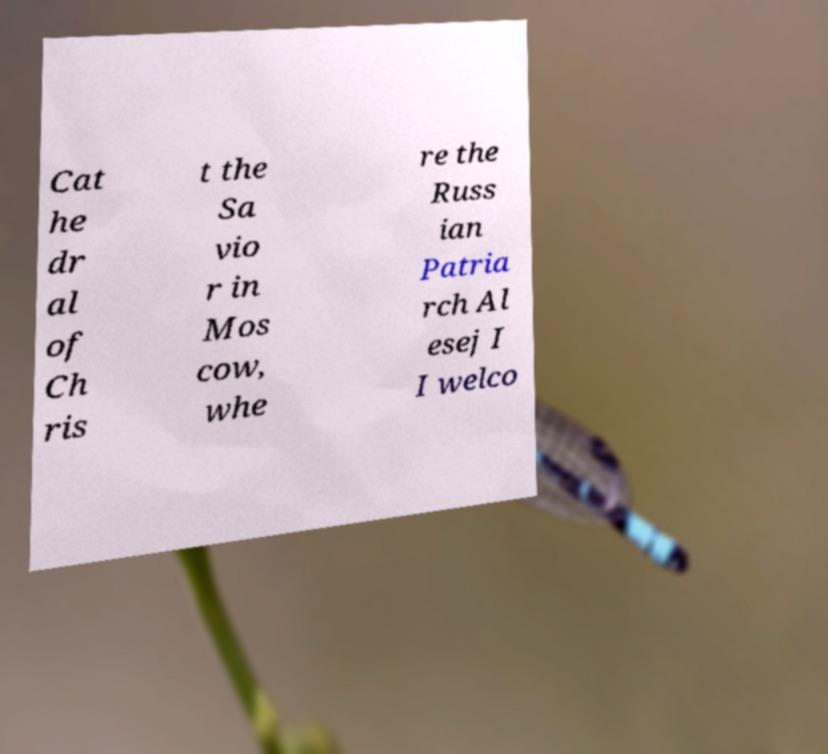There's text embedded in this image that I need extracted. Can you transcribe it verbatim? Cat he dr al of Ch ris t the Sa vio r in Mos cow, whe re the Russ ian Patria rch Al esej I I welco 